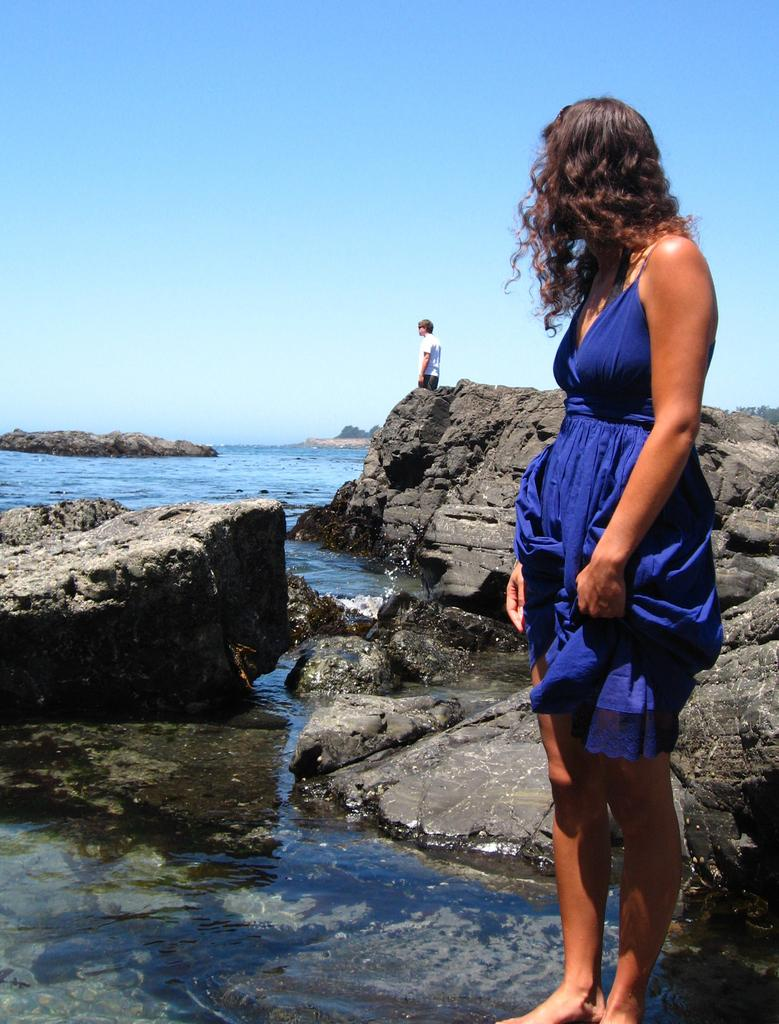What is the woman doing in the image? The woman is standing on a platform in the image. What can be seen in the background behind the woman? Rocks, water, a person, trees, and the sky are visible in the background. Can you describe the setting of the image? The image appears to be set outdoors, with a platform, rocks, water, trees, and the sky visible. What type of jeans is the stove wearing in the image? There is no stove or jeans present in the image. Who is the representative of the person standing in the background? There is no representative mentioned in the image, as it only shows a person standing in the background. 